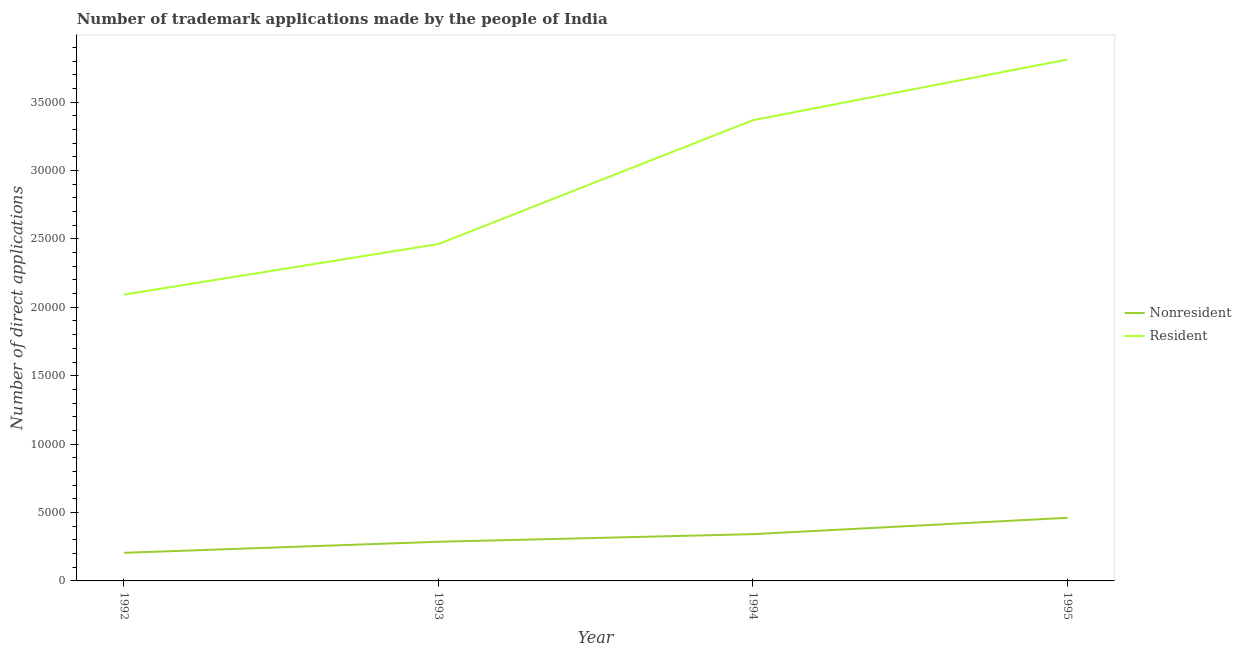Does the line corresponding to number of trademark applications made by non residents intersect with the line corresponding to number of trademark applications made by residents?
Make the answer very short. No. What is the number of trademark applications made by non residents in 1994?
Your answer should be very brief. 3418. Across all years, what is the maximum number of trademark applications made by non residents?
Ensure brevity in your answer.  4614. Across all years, what is the minimum number of trademark applications made by non residents?
Provide a succinct answer. 2054. In which year was the number of trademark applications made by residents maximum?
Offer a terse response. 1995. What is the total number of trademark applications made by residents in the graph?
Give a very brief answer. 1.17e+05. What is the difference between the number of trademark applications made by residents in 1994 and that in 1995?
Make the answer very short. -4430. What is the difference between the number of trademark applications made by non residents in 1993 and the number of trademark applications made by residents in 1995?
Give a very brief answer. -3.52e+04. What is the average number of trademark applications made by non residents per year?
Keep it short and to the point. 3237. In the year 1992, what is the difference between the number of trademark applications made by residents and number of trademark applications made by non residents?
Your answer should be very brief. 1.89e+04. What is the ratio of the number of trademark applications made by residents in 1993 to that in 1994?
Give a very brief answer. 0.73. What is the difference between the highest and the second highest number of trademark applications made by non residents?
Your response must be concise. 1196. What is the difference between the highest and the lowest number of trademark applications made by non residents?
Offer a very short reply. 2560. In how many years, is the number of trademark applications made by residents greater than the average number of trademark applications made by residents taken over all years?
Provide a short and direct response. 2. Does the number of trademark applications made by residents monotonically increase over the years?
Your answer should be very brief. Yes. Does the graph contain any zero values?
Ensure brevity in your answer.  No. Does the graph contain grids?
Provide a short and direct response. No. Where does the legend appear in the graph?
Offer a terse response. Center right. How many legend labels are there?
Your answer should be very brief. 2. How are the legend labels stacked?
Your answer should be compact. Vertical. What is the title of the graph?
Your answer should be compact. Number of trademark applications made by the people of India. What is the label or title of the X-axis?
Your answer should be very brief. Year. What is the label or title of the Y-axis?
Your response must be concise. Number of direct applications. What is the Number of direct applications of Nonresident in 1992?
Offer a very short reply. 2054. What is the Number of direct applications of Resident in 1992?
Provide a short and direct response. 2.09e+04. What is the Number of direct applications in Nonresident in 1993?
Your answer should be compact. 2862. What is the Number of direct applications of Resident in 1993?
Give a very brief answer. 2.46e+04. What is the Number of direct applications in Nonresident in 1994?
Offer a terse response. 3418. What is the Number of direct applications of Resident in 1994?
Offer a terse response. 3.37e+04. What is the Number of direct applications in Nonresident in 1995?
Provide a short and direct response. 4614. What is the Number of direct applications of Resident in 1995?
Your answer should be very brief. 3.81e+04. Across all years, what is the maximum Number of direct applications in Nonresident?
Your answer should be compact. 4614. Across all years, what is the maximum Number of direct applications of Resident?
Provide a short and direct response. 3.81e+04. Across all years, what is the minimum Number of direct applications in Nonresident?
Provide a short and direct response. 2054. Across all years, what is the minimum Number of direct applications in Resident?
Your response must be concise. 2.09e+04. What is the total Number of direct applications of Nonresident in the graph?
Your answer should be compact. 1.29e+04. What is the total Number of direct applications in Resident in the graph?
Your answer should be compact. 1.17e+05. What is the difference between the Number of direct applications of Nonresident in 1992 and that in 1993?
Keep it short and to the point. -808. What is the difference between the Number of direct applications of Resident in 1992 and that in 1993?
Keep it short and to the point. -3695. What is the difference between the Number of direct applications in Nonresident in 1992 and that in 1994?
Your response must be concise. -1364. What is the difference between the Number of direct applications in Resident in 1992 and that in 1994?
Your response must be concise. -1.28e+04. What is the difference between the Number of direct applications in Nonresident in 1992 and that in 1995?
Offer a very short reply. -2560. What is the difference between the Number of direct applications in Resident in 1992 and that in 1995?
Offer a very short reply. -1.72e+04. What is the difference between the Number of direct applications of Nonresident in 1993 and that in 1994?
Your answer should be compact. -556. What is the difference between the Number of direct applications of Resident in 1993 and that in 1994?
Offer a terse response. -9056. What is the difference between the Number of direct applications in Nonresident in 1993 and that in 1995?
Give a very brief answer. -1752. What is the difference between the Number of direct applications in Resident in 1993 and that in 1995?
Make the answer very short. -1.35e+04. What is the difference between the Number of direct applications of Nonresident in 1994 and that in 1995?
Your response must be concise. -1196. What is the difference between the Number of direct applications of Resident in 1994 and that in 1995?
Keep it short and to the point. -4430. What is the difference between the Number of direct applications in Nonresident in 1992 and the Number of direct applications in Resident in 1993?
Keep it short and to the point. -2.26e+04. What is the difference between the Number of direct applications in Nonresident in 1992 and the Number of direct applications in Resident in 1994?
Your response must be concise. -3.16e+04. What is the difference between the Number of direct applications of Nonresident in 1992 and the Number of direct applications of Resident in 1995?
Offer a terse response. -3.61e+04. What is the difference between the Number of direct applications in Nonresident in 1993 and the Number of direct applications in Resident in 1994?
Offer a terse response. -3.08e+04. What is the difference between the Number of direct applications in Nonresident in 1993 and the Number of direct applications in Resident in 1995?
Give a very brief answer. -3.52e+04. What is the difference between the Number of direct applications in Nonresident in 1994 and the Number of direct applications in Resident in 1995?
Offer a very short reply. -3.47e+04. What is the average Number of direct applications of Nonresident per year?
Offer a terse response. 3237. What is the average Number of direct applications of Resident per year?
Provide a succinct answer. 2.93e+04. In the year 1992, what is the difference between the Number of direct applications of Nonresident and Number of direct applications of Resident?
Keep it short and to the point. -1.89e+04. In the year 1993, what is the difference between the Number of direct applications in Nonresident and Number of direct applications in Resident?
Provide a short and direct response. -2.18e+04. In the year 1994, what is the difference between the Number of direct applications in Nonresident and Number of direct applications in Resident?
Keep it short and to the point. -3.03e+04. In the year 1995, what is the difference between the Number of direct applications in Nonresident and Number of direct applications in Resident?
Your answer should be compact. -3.35e+04. What is the ratio of the Number of direct applications of Nonresident in 1992 to that in 1993?
Make the answer very short. 0.72. What is the ratio of the Number of direct applications of Resident in 1992 to that in 1993?
Give a very brief answer. 0.85. What is the ratio of the Number of direct applications in Nonresident in 1992 to that in 1994?
Ensure brevity in your answer.  0.6. What is the ratio of the Number of direct applications in Resident in 1992 to that in 1994?
Offer a very short reply. 0.62. What is the ratio of the Number of direct applications in Nonresident in 1992 to that in 1995?
Provide a succinct answer. 0.45. What is the ratio of the Number of direct applications in Resident in 1992 to that in 1995?
Keep it short and to the point. 0.55. What is the ratio of the Number of direct applications of Nonresident in 1993 to that in 1994?
Your response must be concise. 0.84. What is the ratio of the Number of direct applications of Resident in 1993 to that in 1994?
Your answer should be very brief. 0.73. What is the ratio of the Number of direct applications in Nonresident in 1993 to that in 1995?
Offer a very short reply. 0.62. What is the ratio of the Number of direct applications of Resident in 1993 to that in 1995?
Your answer should be very brief. 0.65. What is the ratio of the Number of direct applications of Nonresident in 1994 to that in 1995?
Your answer should be compact. 0.74. What is the ratio of the Number of direct applications in Resident in 1994 to that in 1995?
Make the answer very short. 0.88. What is the difference between the highest and the second highest Number of direct applications in Nonresident?
Give a very brief answer. 1196. What is the difference between the highest and the second highest Number of direct applications of Resident?
Provide a short and direct response. 4430. What is the difference between the highest and the lowest Number of direct applications in Nonresident?
Your response must be concise. 2560. What is the difference between the highest and the lowest Number of direct applications of Resident?
Provide a short and direct response. 1.72e+04. 